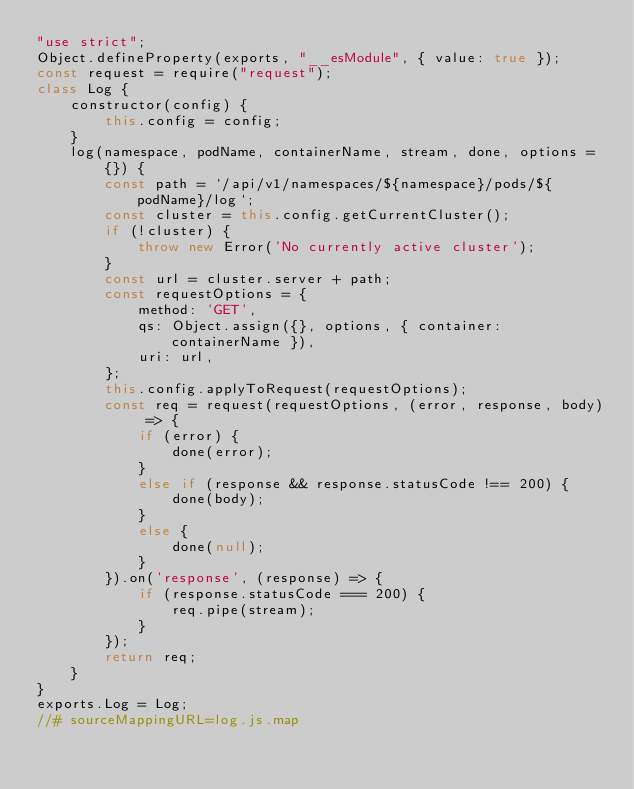Convert code to text. <code><loc_0><loc_0><loc_500><loc_500><_JavaScript_>"use strict";
Object.defineProperty(exports, "__esModule", { value: true });
const request = require("request");
class Log {
    constructor(config) {
        this.config = config;
    }
    log(namespace, podName, containerName, stream, done, options = {}) {
        const path = `/api/v1/namespaces/${namespace}/pods/${podName}/log`;
        const cluster = this.config.getCurrentCluster();
        if (!cluster) {
            throw new Error('No currently active cluster');
        }
        const url = cluster.server + path;
        const requestOptions = {
            method: 'GET',
            qs: Object.assign({}, options, { container: containerName }),
            uri: url,
        };
        this.config.applyToRequest(requestOptions);
        const req = request(requestOptions, (error, response, body) => {
            if (error) {
                done(error);
            }
            else if (response && response.statusCode !== 200) {
                done(body);
            }
            else {
                done(null);
            }
        }).on('response', (response) => {
            if (response.statusCode === 200) {
                req.pipe(stream);
            }
        });
        return req;
    }
}
exports.Log = Log;
//# sourceMappingURL=log.js.map</code> 